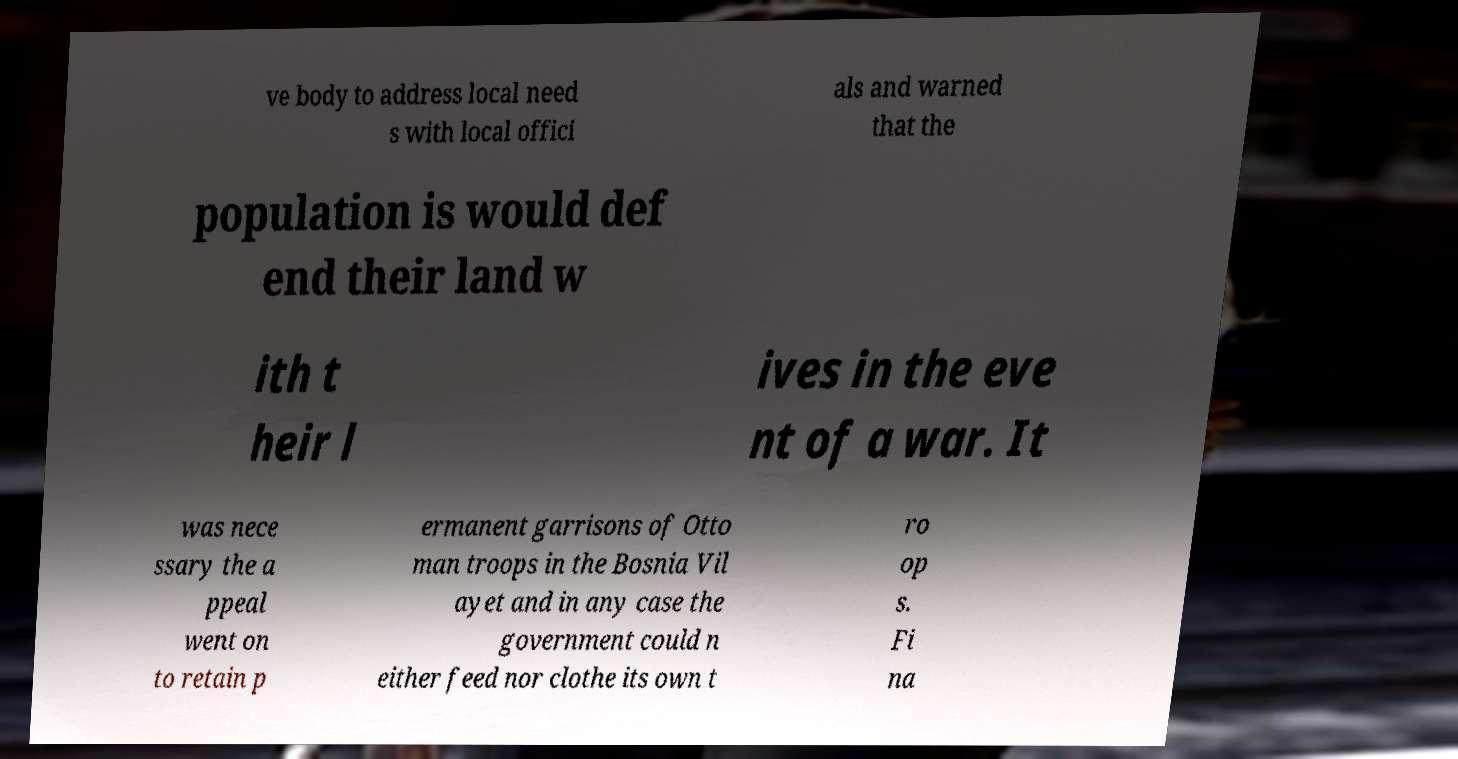What messages or text are displayed in this image? I need them in a readable, typed format. ve body to address local need s with local offici als and warned that the population is would def end their land w ith t heir l ives in the eve nt of a war. It was nece ssary the a ppeal went on to retain p ermanent garrisons of Otto man troops in the Bosnia Vil ayet and in any case the government could n either feed nor clothe its own t ro op s. Fi na 